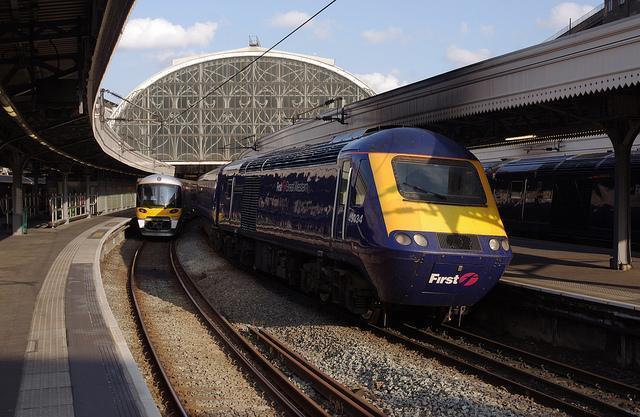How many trains?
Give a very brief answer. 2. How many trains are in the picture?
Give a very brief answer. 3. How many giraffes are looking away from the camera?
Give a very brief answer. 0. 